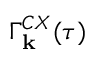<formula> <loc_0><loc_0><loc_500><loc_500>\Gamma _ { k } ^ { C X } ( \tau )</formula> 